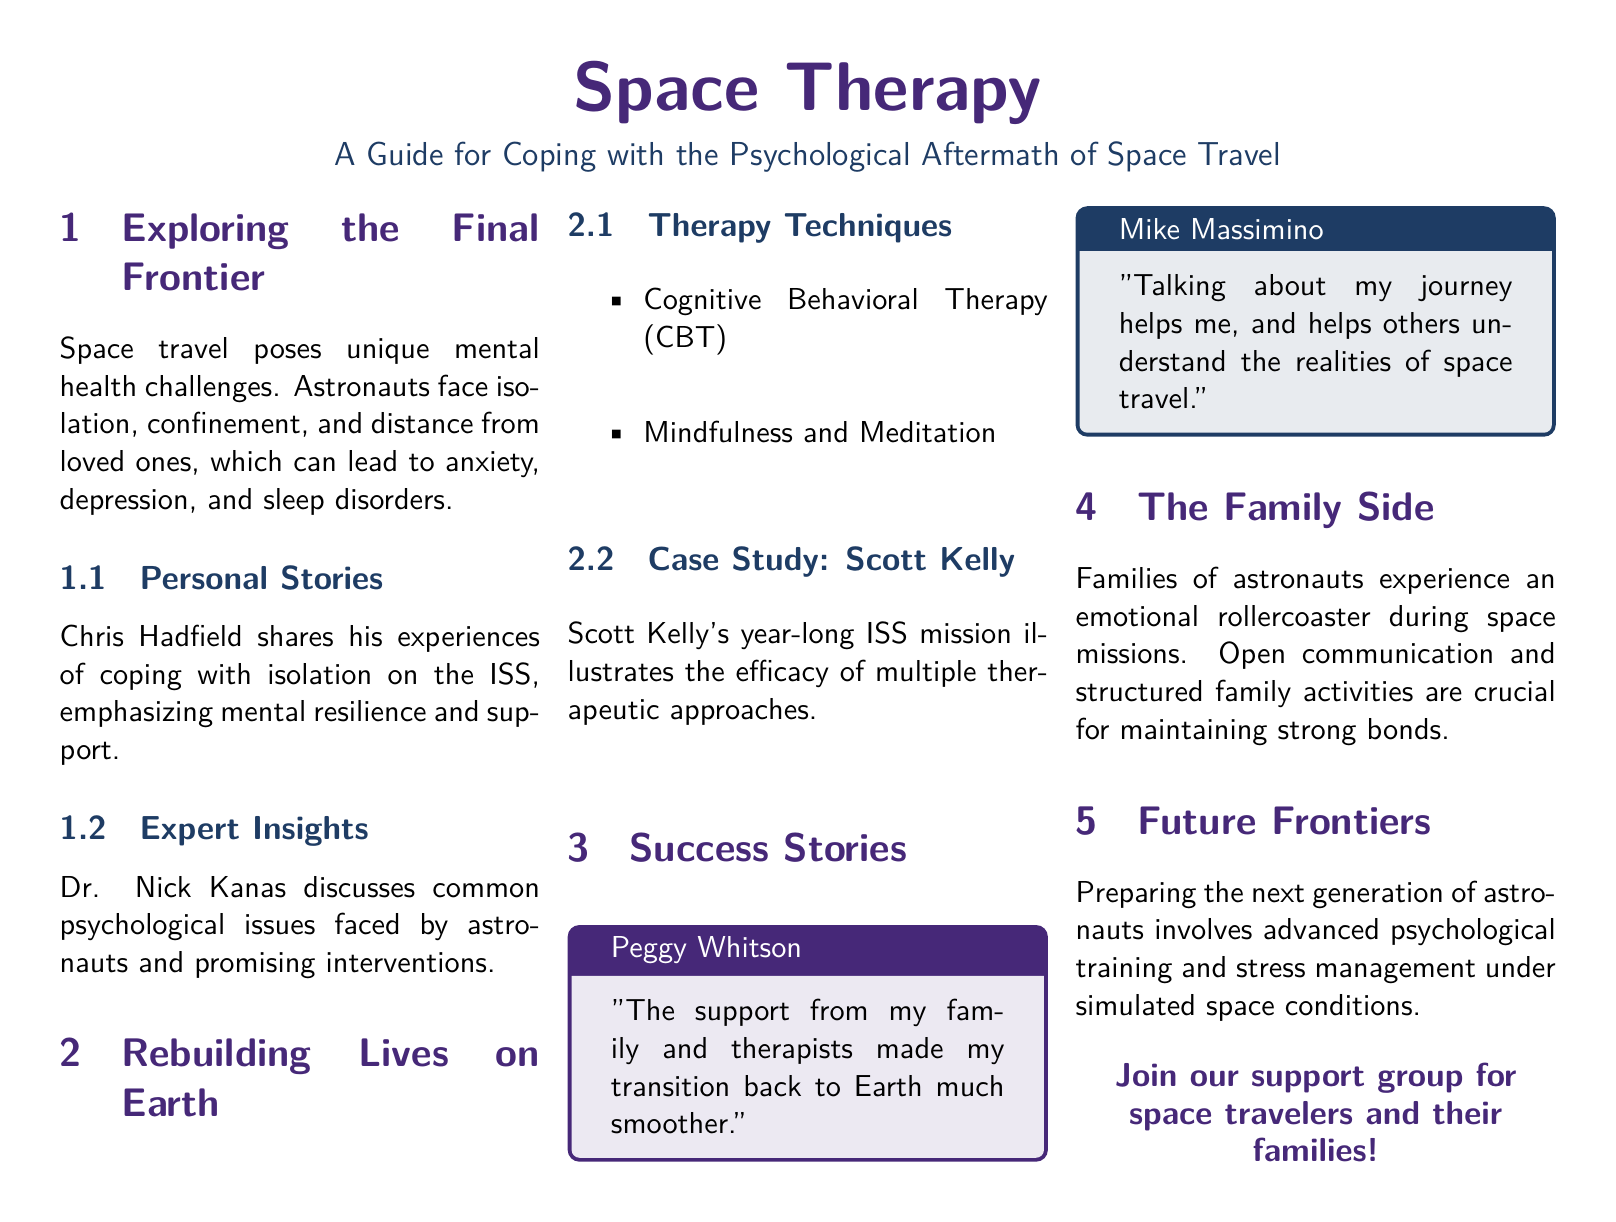what are the unique mental health challenges faced by astronauts? The document mentions isolation, confinement, and distance from loved ones as unique mental health challenges that astronauts face.
Answer: isolation, confinement, and distance from loved ones who discusses common psychological issues faced by astronauts? The document references Dr. Nick Kanas as the expert discussing common psychological issues faced by astronauts and promising interventions.
Answer: Dr. Nick Kanas what therapy technique is mentioned along with Cognitive Behavioral Therapy? The document lists "Mindfulness and Meditation" as a therapy technique alongside Cognitive Behavioral Therapy (CBT).
Answer: Mindfulness and Meditation who provides a notable quote about emotional support during transition? The document includes a quote from Peggy Whitson regarding the support that helped her transition back to Earth.
Answer: Peggy Whitson how many case studies are mentioned in the therapy techniques section? The document includes a single case study related to therapy techniques, specifically Scott Kelly's experiences.
Answer: One what is crucial for families of astronauts to maintain strong bonds? The document states that "Open communication and structured family activities" are crucial for families of astronauts during missions.
Answer: Open communication and structured family activities what is the focus of the section titled "Future Frontiers"? The section emphasizes preparing the next generation of astronauts through advanced psychological training and stress management.
Answer: preparing the next generation of astronauts who emphasizes the importance of talking about the journey? The document quotes Mike Massimino emphasizing that talking about his journey helps both him and others.
Answer: Mike Massimino 